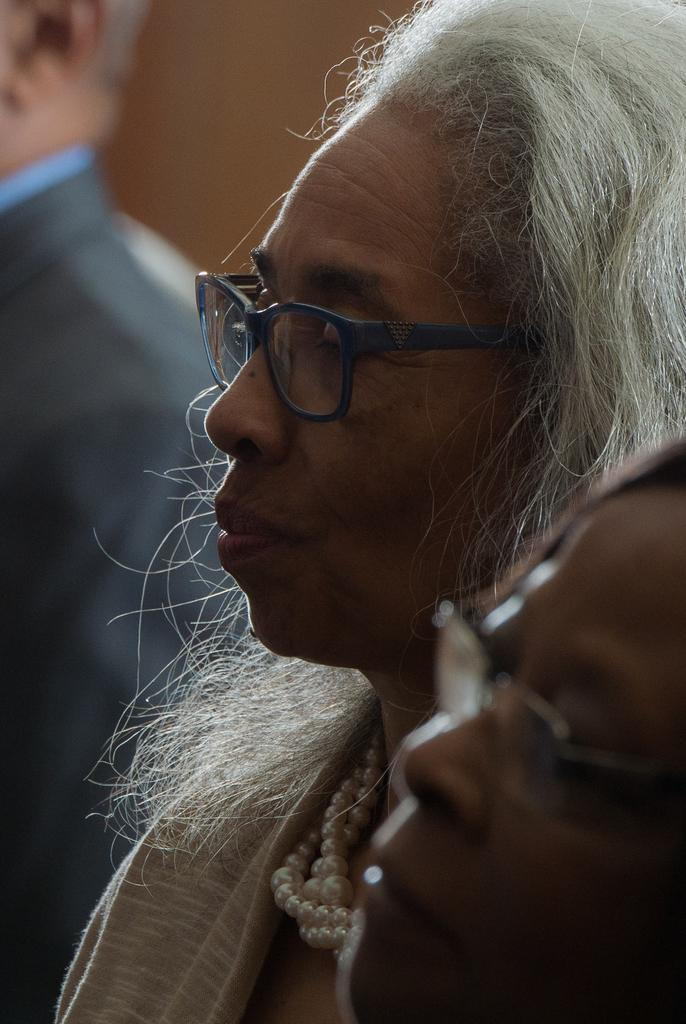How many people are in the foreground of the image? There are two women in the foreground of the image. What is the gender of the person in the background of the image? There is a man in the background of the image. What can be seen in the background of the image? There is a wall in the background of the image. What type of lead is being used by the women in the image? There is no lead present in the image, and the women are not using any lead. 